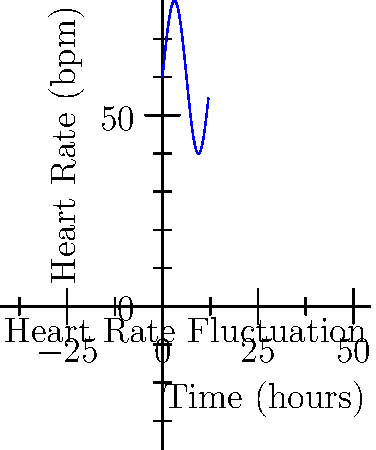As a caregiver monitoring an elderly patient's heart rate over 12 hours, you observe fluctuations represented by the function $f(t) = 60 + 20\sin(\frac{t}{2})$, where $t$ is time in hours and $f(t)$ is heart rate in beats per minute. Calculate the total number of heartbeats over this 12-hour period. To find the total number of heartbeats, we need to calculate the area under the curve of the heart rate function over the 12-hour period. This can be done using integration:

1) Set up the integral:
   $$\int_0^{12} (60 + 20\sin(\frac{t}{2})) dt$$

2) Integrate the function:
   $$= [60t - 40\cos(\frac{t}{2})]_0^{12}$$

3) Evaluate the integral:
   $$= (60 \cdot 12 - 40\cos(6)) - (60 \cdot 0 - 40\cos(0))$$
   $$= (720 - 40\cos(6)) - (-40)$$
   $$= 720 - 40\cos(6) + 40$$

4) Simplify:
   $$= 760 - 40\cos(6)$$
   $$\approx 760 - 40(-0.960)$$
   $$\approx 760 + 38.4$$
   $$\approx 798.4$$

5) Round to the nearest whole number, as we can't have a fraction of a heartbeat:
   $$\approx 798 \text{ beats}$$
Answer: 798 heartbeats 